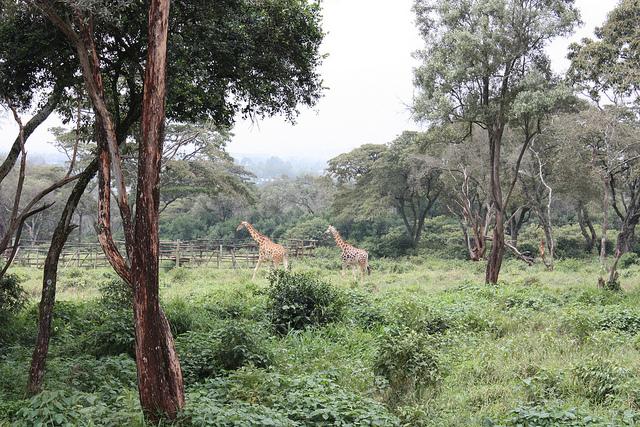Is this taken indoors?
Quick response, please. No. Are these animals running in the plain?
Give a very brief answer. No. How many animals are there?
Short answer required. 2. How many animals can be seen?
Give a very brief answer. 2. 